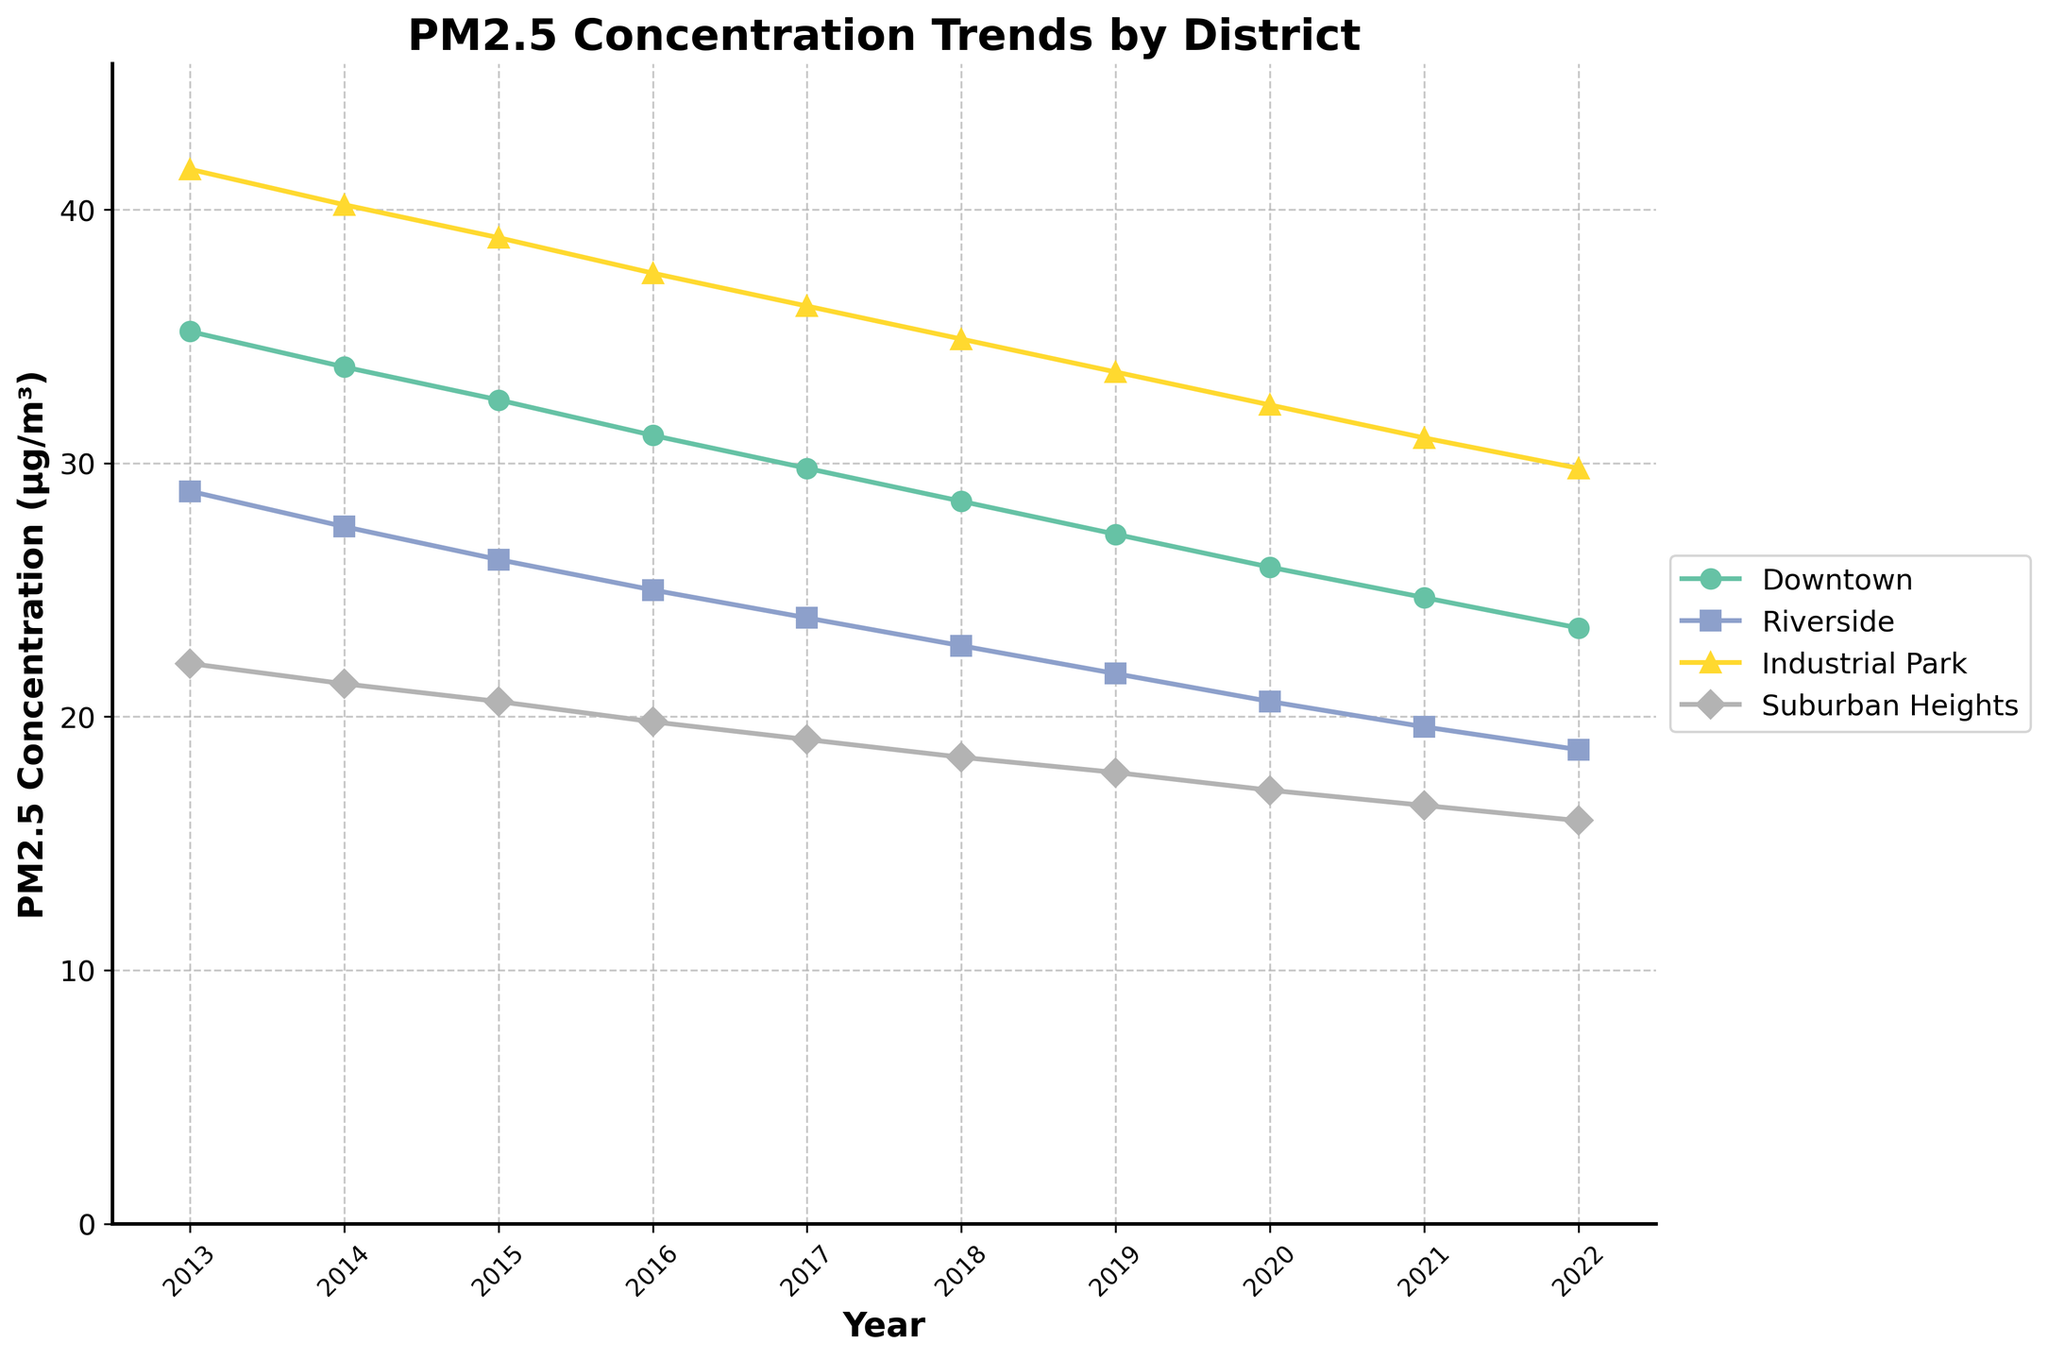what is the overall trend of PM2.5 concentration in Downtown from 2013 to 2022? The line for Downtown shows a continuous downward trend from 2013 to 2022, which indicates a decrease in PM2.5 concentration over the 10-year period
Answer: A decreasing trend which district had the highest PM2.5 concentration in 2016? In 2016, the line chart shows that Industrial Park had the highest PM2.5 concentration as its point is the highest among the districts listed
Answer: Industrial Park how does the PM2.5 concentration in Suburban Heights compare to Riverside in 2020? In 2020, the PM2.5 concentration in Suburban Heights was lower than in Riverside. The line representing Suburban Heights is lower than the line for Riverside
Answer: Suburban Heights is lower which year shows the largest difference in PM2.5 concentration between Downtown and Industrial Park? By comparing the distances between the two lines, the year 2013 shows the largest difference, where Industrial Park's line is significantly higher than Downtown's
Answer: 2013 what is the average PM2.5 concentration in Riverside over 10 years? Sum the PM2.5 values for Riverside (28.9, 27.5, 26.2, 25.0, 23.9, 22.8, 21.7, 20.6, 19.6, 18.7) and divide by the number of years (10). The sum is 235.9, so the average is 235.9/10 = 23.59
Answer: 23.59 which year saw the largest decrease in PM2.5 concentration for Industrial Park from the previous year? Calculate the yearly differences and compare: the largest decrease is between 2021 (31.0) and 2022 (29.8) from the previous year, which is 31.0 - 29.8 = 1.2
Answer: Between 2021 and 2022 considering the visual attributes, which district consistently had the lowest PM2.5 concentration over the years? By observing the lines, Suburban Heights consistently has the lowest points each year, indicating the lowest PM2.5 concentration
Answer: Suburban Heights 